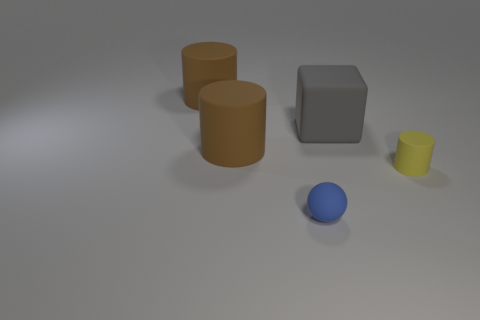Is there any other thing of the same color as the block?
Your answer should be very brief. No. Are there any other large objects that have the same shape as the yellow thing?
Your answer should be very brief. Yes. Does the object that is behind the big rubber block have the same size as the cylinder that is right of the blue thing?
Make the answer very short. No. Are there more large gray rubber blocks than blue shiny cylinders?
Make the answer very short. Yes. What number of brown cylinders are made of the same material as the small yellow cylinder?
Your answer should be very brief. 2. There is a gray matte cube that is behind the small object that is behind the small rubber object that is in front of the tiny yellow rubber cylinder; what is its size?
Provide a short and direct response. Large. Is there a tiny sphere that is on the left side of the brown matte object behind the big rubber cube?
Your response must be concise. No. What number of large cylinders are behind the cylinder left of the large matte cylinder in front of the gray matte object?
Offer a very short reply. 0. What color is the thing that is both right of the ball and left of the yellow matte object?
Keep it short and to the point. Gray. How many cylinders are tiny rubber objects or blue rubber things?
Ensure brevity in your answer.  1. 